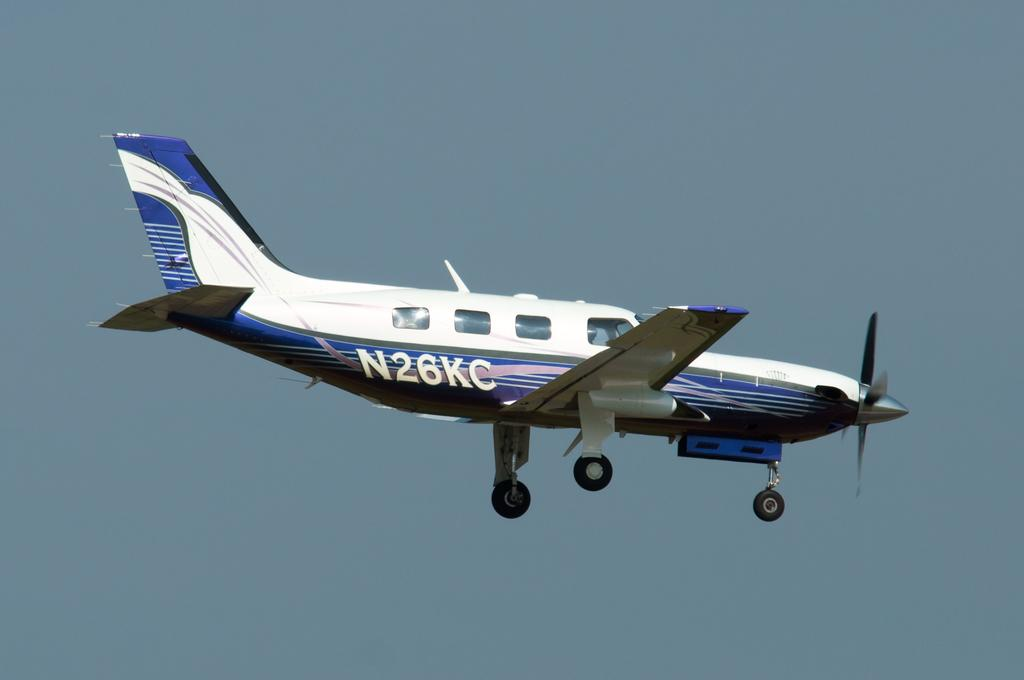<image>
Summarize the visual content of the image. A blue and white plane with the tail number of N26KC is in flight. 